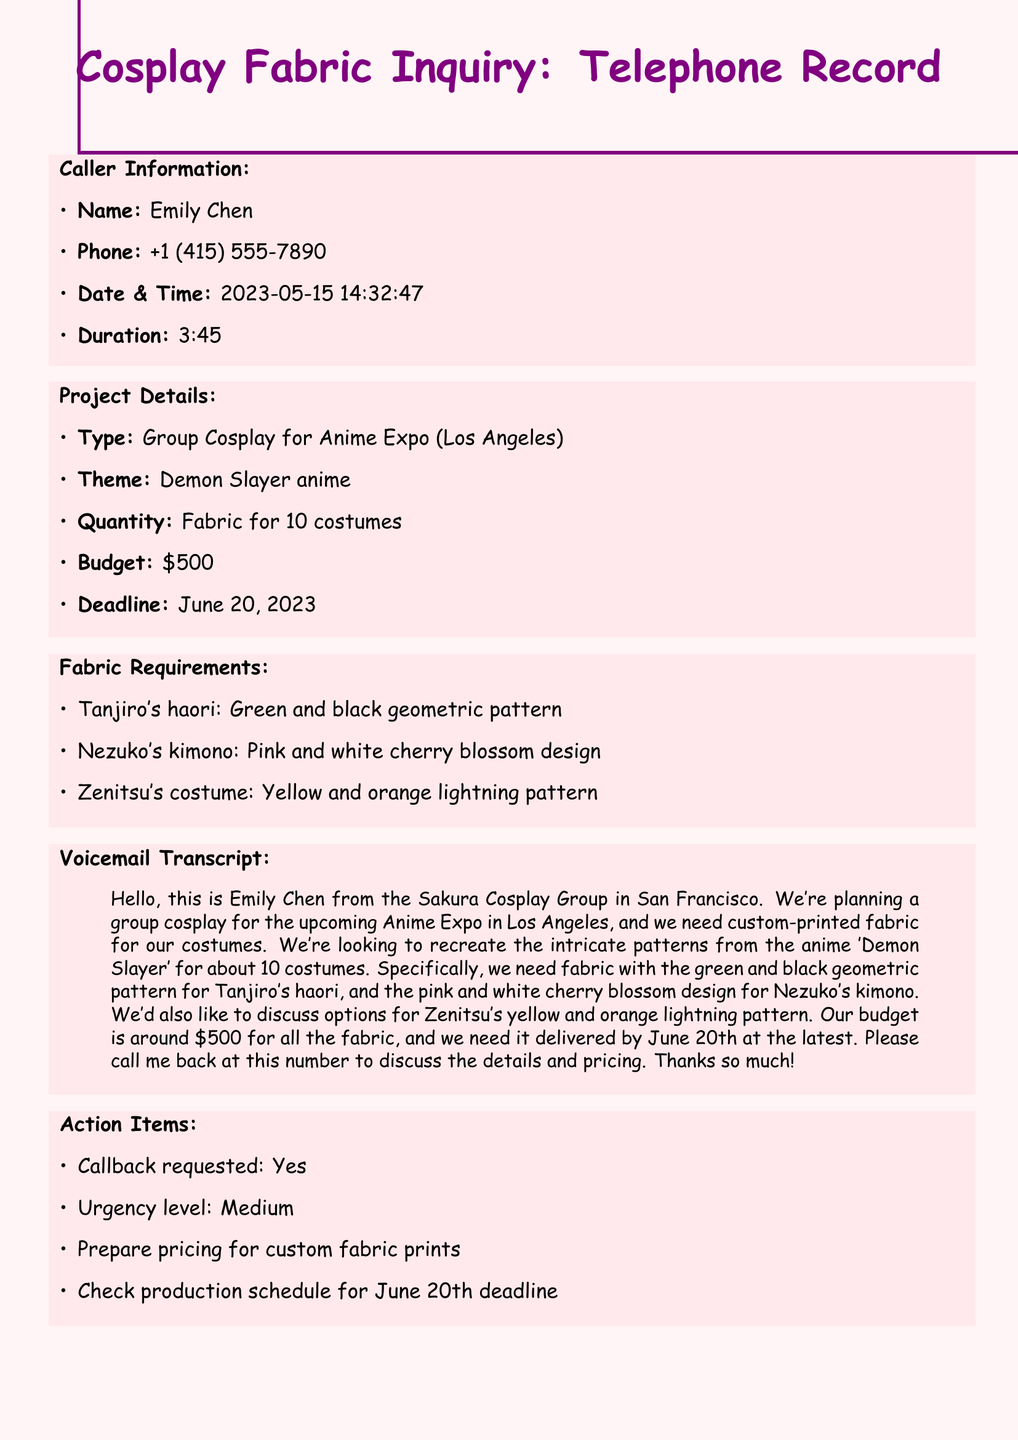What is the caller's name? The caller's name is listed in the Caller Information section of the document.
Answer: Emily Chen What is the contact number of the caller? The contact number is provided in the Caller Information section.
Answer: +1 (415) 555-7890 What is the budget for the fabric? The budget is mentioned in the Project Details section of the document.
Answer: $500 How many costumes are being planned? The quantity of costumes is outlined in the Project Details section.
Answer: 10 What is the deadline for the fabric delivery? The deadline is provided in the Project Details and indicates when the fabric needs to be delivered.
Answer: June 20, 2023 Which anime is the cosplay project based on? The theme of the cosplay project is specified in the Project Details.
Answer: Demon Slayer What is the main color pattern for Tanjiro's haori? The fabric requirement specifies the pattern colors for Tanjiro’s haori.
Answer: Green and black geometric pattern Is a callback requested? The Action Items section indicates whether a callback is requested.
Answer: Yes What is the urgency level of the request? The urgency level is categorized in the Action Items section.
Answer: Medium 